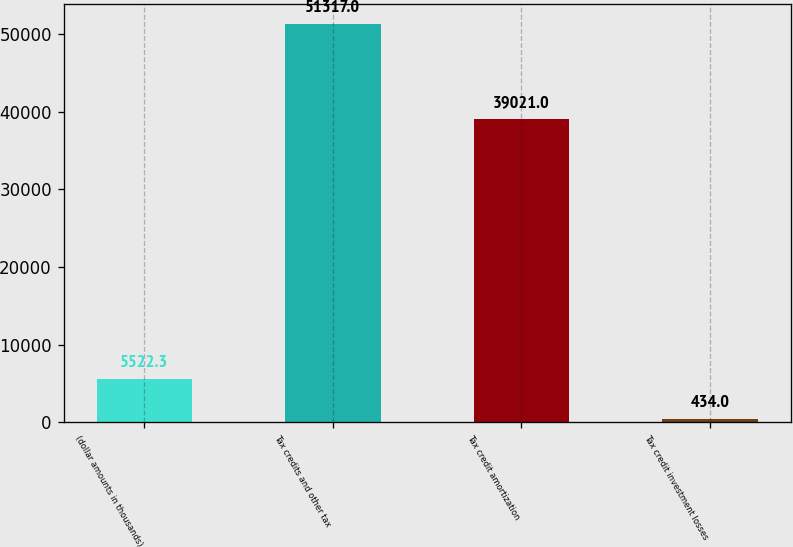Convert chart. <chart><loc_0><loc_0><loc_500><loc_500><bar_chart><fcel>(dollar amounts in thousands)<fcel>Tax credits and other tax<fcel>Tax credit amortization<fcel>Tax credit investment losses<nl><fcel>5522.3<fcel>51317<fcel>39021<fcel>434<nl></chart> 